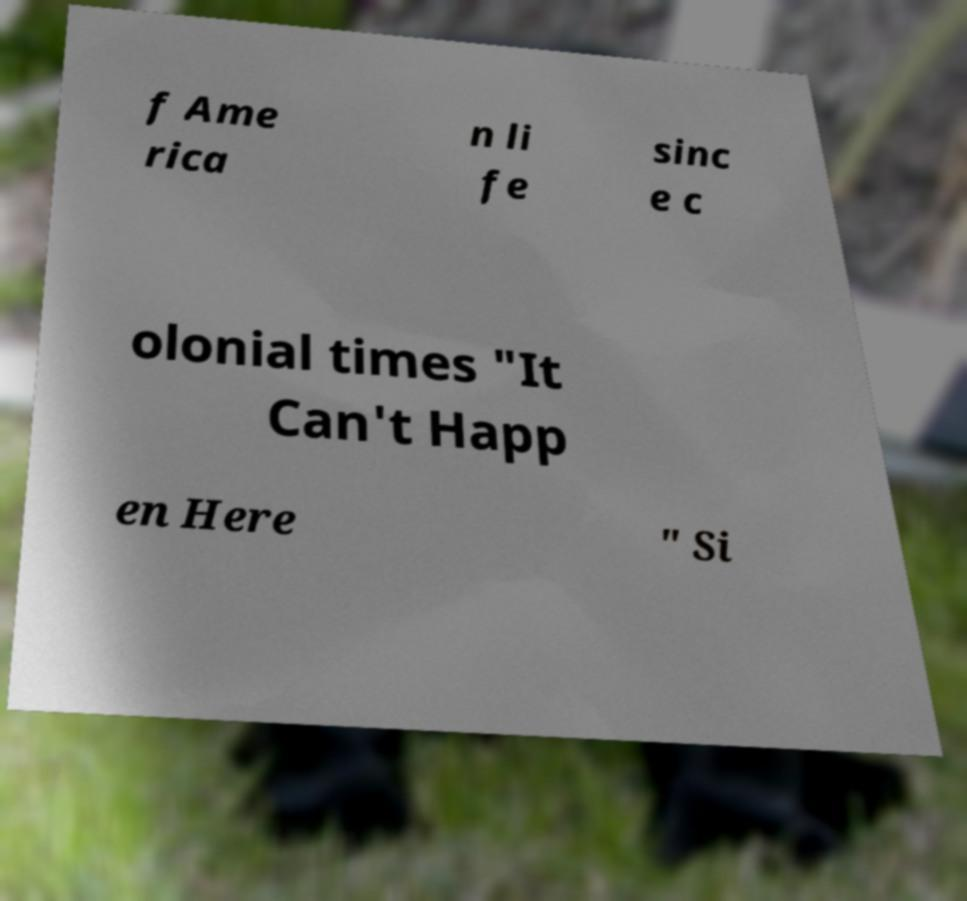Please identify and transcribe the text found in this image. f Ame rica n li fe sinc e c olonial times "It Can't Happ en Here " Si 